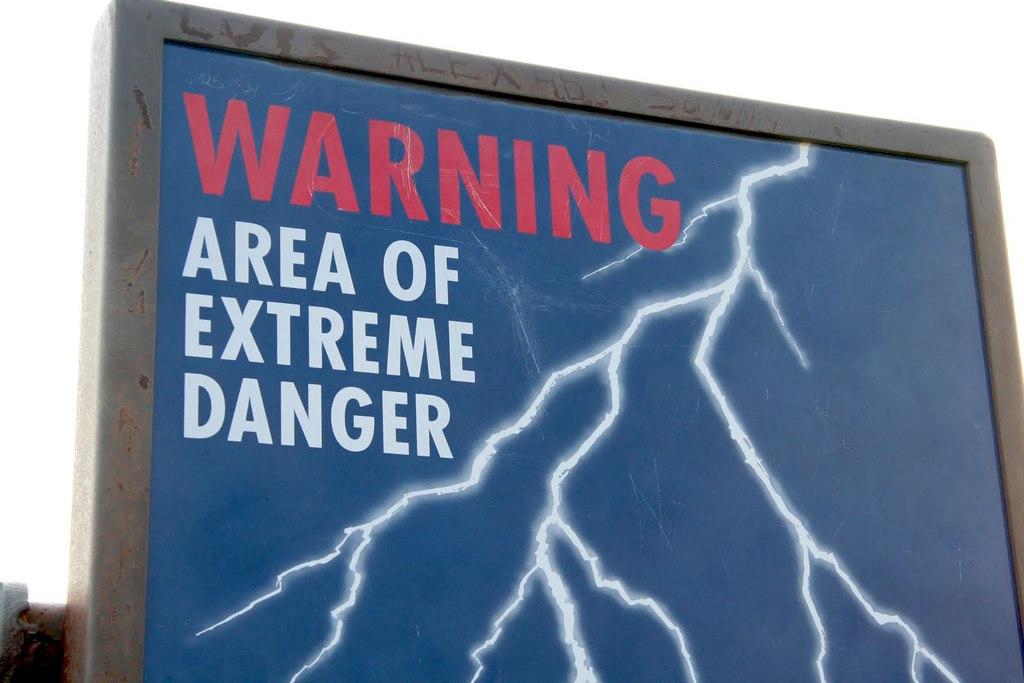Is there danger in the area?
Keep it short and to the point. Yes. What does the text say in red?
Provide a short and direct response. Warning. 